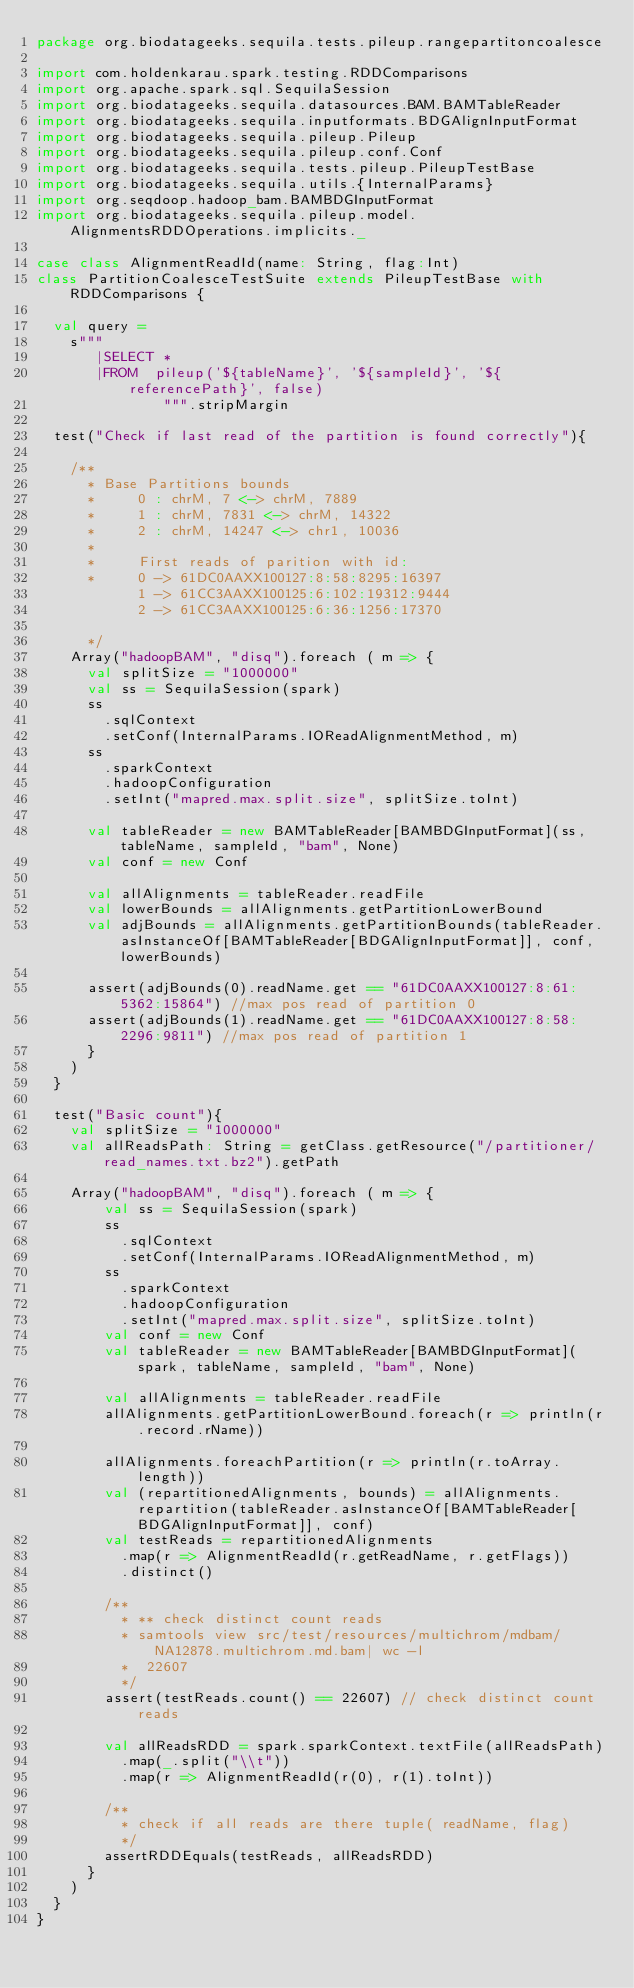<code> <loc_0><loc_0><loc_500><loc_500><_Scala_>package org.biodatageeks.sequila.tests.pileup.rangepartitoncoalesce

import com.holdenkarau.spark.testing.RDDComparisons
import org.apache.spark.sql.SequilaSession
import org.biodatageeks.sequila.datasources.BAM.BAMTableReader
import org.biodatageeks.sequila.inputformats.BDGAlignInputFormat
import org.biodatageeks.sequila.pileup.Pileup
import org.biodatageeks.sequila.pileup.conf.Conf
import org.biodatageeks.sequila.tests.pileup.PileupTestBase
import org.biodatageeks.sequila.utils.{InternalParams}
import org.seqdoop.hadoop_bam.BAMBDGInputFormat
import org.biodatageeks.sequila.pileup.model.AlignmentsRDDOperations.implicits._

case class AlignmentReadId(name: String, flag:Int)
class PartitionCoalesceTestSuite extends PileupTestBase with RDDComparisons {

  val query =
    s"""
       |SELECT *
       |FROM  pileup('${tableName}', '${sampleId}', '${referencePath}', false)
               """.stripMargin

  test("Check if last read of the partition is found correctly"){

    /**
      * Base Partitions bounds
      *     0 : chrM, 7 <-> chrM, 7889
      *     1 : chrM, 7831 <-> chrM, 14322
      *     2 : chrM, 14247 <-> chr1, 10036
      *
      *     First reads of parition with id:
      *     0 -> 61DC0AAXX100127:8:58:8295:16397
            1 -> 61CC3AAXX100125:6:102:19312:9444
            2 -> 61CC3AAXX100125:6:36:1256:17370

      */
    Array("hadoopBAM", "disq").foreach ( m => {
      val splitSize = "1000000"
      val ss = SequilaSession(spark)
      ss
        .sqlContext
        .setConf(InternalParams.IOReadAlignmentMethod, m)
      ss
        .sparkContext
        .hadoopConfiguration
        .setInt("mapred.max.split.size", splitSize.toInt)

      val tableReader = new BAMTableReader[BAMBDGInputFormat](ss, tableName, sampleId, "bam", None)
      val conf = new Conf

      val allAlignments = tableReader.readFile
      val lowerBounds = allAlignments.getPartitionLowerBound
      val adjBounds = allAlignments.getPartitionBounds(tableReader.asInstanceOf[BAMTableReader[BDGAlignInputFormat]], conf, lowerBounds)

      assert(adjBounds(0).readName.get == "61DC0AAXX100127:8:61:5362:15864") //max pos read of partition 0
      assert(adjBounds(1).readName.get == "61DC0AAXX100127:8:58:2296:9811") //max pos read of partition 1
      }
    )
  }

  test("Basic count"){
    val splitSize = "1000000"
    val allReadsPath: String = getClass.getResource("/partitioner/read_names.txt.bz2").getPath

    Array("hadoopBAM", "disq").foreach ( m => {
        val ss = SequilaSession(spark)
        ss
          .sqlContext
          .setConf(InternalParams.IOReadAlignmentMethod, m)
        ss
          .sparkContext
          .hadoopConfiguration
          .setInt("mapred.max.split.size", splitSize.toInt)
        val conf = new Conf
        val tableReader = new BAMTableReader[BAMBDGInputFormat](spark, tableName, sampleId, "bam", None)

        val allAlignments = tableReader.readFile
        allAlignments.getPartitionLowerBound.foreach(r => println(r.record.rName))

        allAlignments.foreachPartition(r => println(r.toArray.length))
        val (repartitionedAlignments, bounds) = allAlignments.repartition(tableReader.asInstanceOf[BAMTableReader[BDGAlignInputFormat]], conf)
        val testReads = repartitionedAlignments
          .map(r => AlignmentReadId(r.getReadName, r.getFlags))
          .distinct()

        /**
          * ** check distinct count reads
          * samtools view src/test/resources/multichrom/mdbam/NA12878.multichrom.md.bam| wc -l
          *  22607
          */
        assert(testReads.count() == 22607) // check distinct count reads

        val allReadsRDD = spark.sparkContext.textFile(allReadsPath)
          .map(_.split("\\t"))
          .map(r => AlignmentReadId(r(0), r(1).toInt))

        /**
          * check if all reads are there tuple( readName, flag)
          */
        assertRDDEquals(testReads, allReadsRDD)
      }
    )
  }
}
</code> 